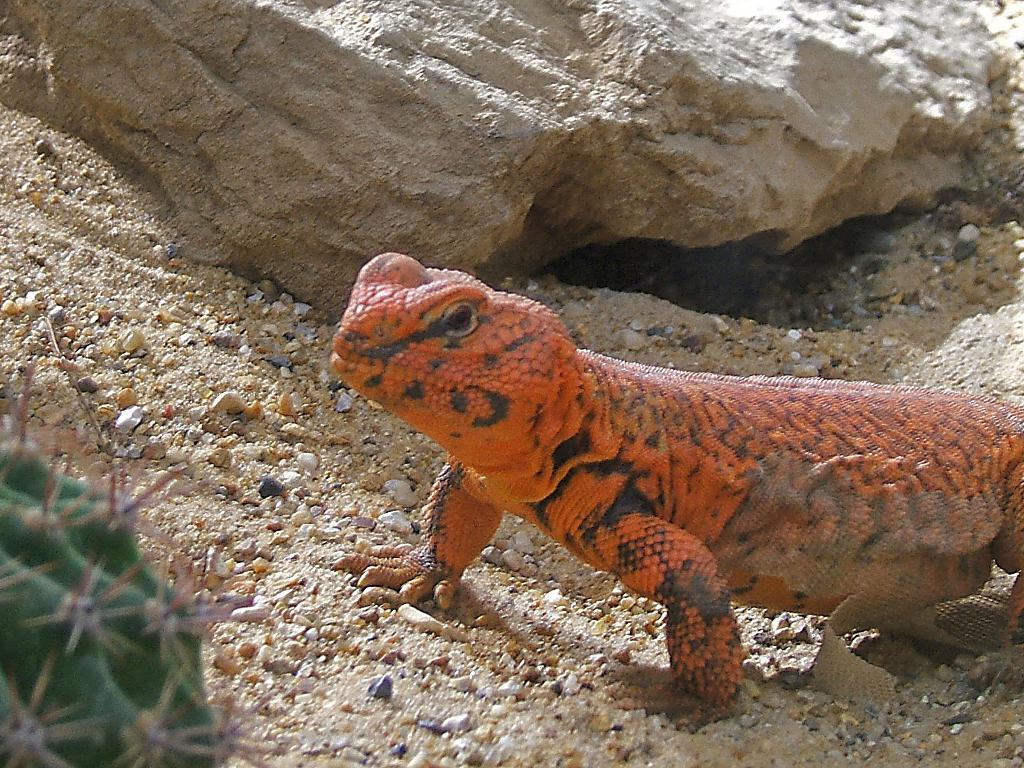What type of animal is in the picture? There is an orange color lizard in the picture. Where is the lizard located? The lizard is on the ground. What can be seen in the background of the image? There are small rocks visible in the background. How many pies are being served by the lizard in the image? There are no pies present in the image, and the lizard is not serving anything. 